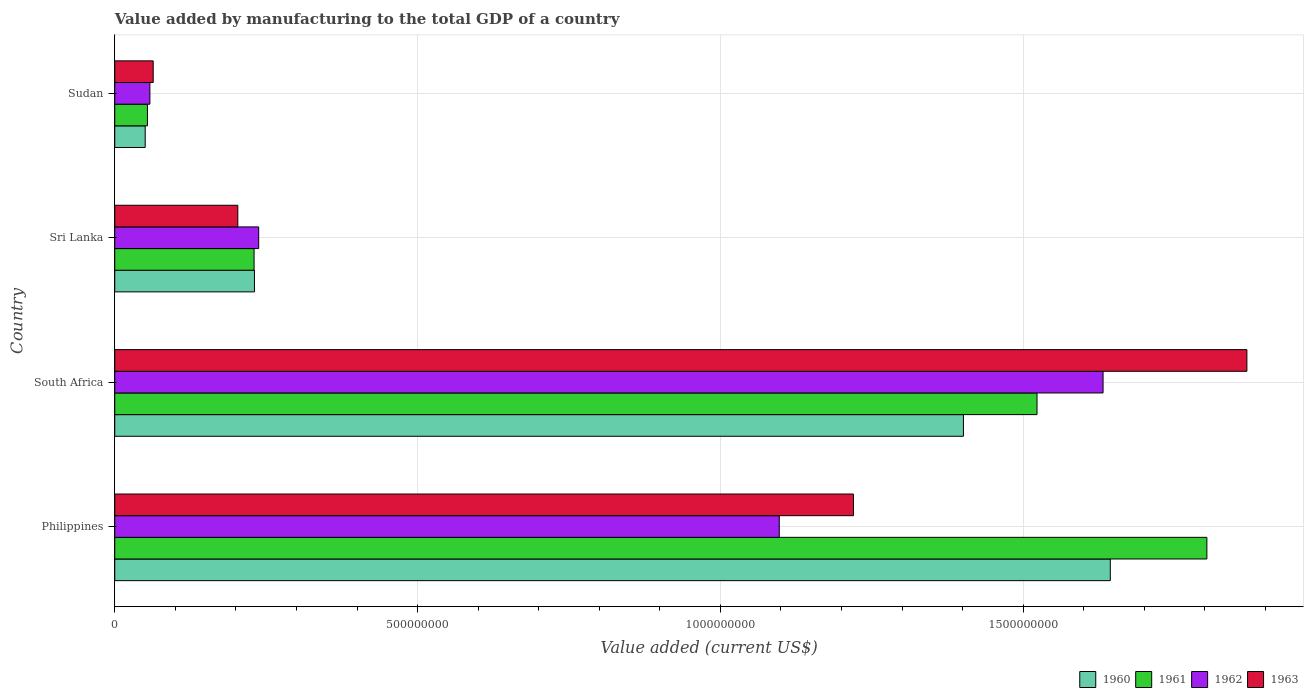Are the number of bars per tick equal to the number of legend labels?
Offer a terse response. Yes. How many bars are there on the 3rd tick from the bottom?
Give a very brief answer. 4. What is the value added by manufacturing to the total GDP in 1963 in Sudan?
Ensure brevity in your answer.  6.35e+07. Across all countries, what is the maximum value added by manufacturing to the total GDP in 1960?
Provide a short and direct response. 1.64e+09. Across all countries, what is the minimum value added by manufacturing to the total GDP in 1962?
Your response must be concise. 5.80e+07. In which country was the value added by manufacturing to the total GDP in 1963 maximum?
Offer a terse response. South Africa. In which country was the value added by manufacturing to the total GDP in 1961 minimum?
Your answer should be very brief. Sudan. What is the total value added by manufacturing to the total GDP in 1960 in the graph?
Offer a terse response. 3.33e+09. What is the difference between the value added by manufacturing to the total GDP in 1961 in Philippines and that in Sudan?
Your response must be concise. 1.75e+09. What is the difference between the value added by manufacturing to the total GDP in 1960 in Sudan and the value added by manufacturing to the total GDP in 1962 in Philippines?
Your response must be concise. -1.05e+09. What is the average value added by manufacturing to the total GDP in 1963 per country?
Your response must be concise. 8.39e+08. What is the difference between the value added by manufacturing to the total GDP in 1963 and value added by manufacturing to the total GDP in 1962 in Sudan?
Your answer should be compact. 5.46e+06. What is the ratio of the value added by manufacturing to the total GDP in 1962 in South Africa to that in Sudan?
Give a very brief answer. 28.13. Is the difference between the value added by manufacturing to the total GDP in 1963 in South Africa and Sri Lanka greater than the difference between the value added by manufacturing to the total GDP in 1962 in South Africa and Sri Lanka?
Provide a succinct answer. Yes. What is the difference between the highest and the second highest value added by manufacturing to the total GDP in 1961?
Your answer should be very brief. 2.80e+08. What is the difference between the highest and the lowest value added by manufacturing to the total GDP in 1961?
Your answer should be very brief. 1.75e+09. In how many countries, is the value added by manufacturing to the total GDP in 1961 greater than the average value added by manufacturing to the total GDP in 1961 taken over all countries?
Provide a short and direct response. 2. Is the sum of the value added by manufacturing to the total GDP in 1960 in South Africa and Sudan greater than the maximum value added by manufacturing to the total GDP in 1961 across all countries?
Your answer should be compact. No. What does the 1st bar from the bottom in Sri Lanka represents?
Give a very brief answer. 1960. How many bars are there?
Your answer should be compact. 16. How many countries are there in the graph?
Offer a very short reply. 4. Does the graph contain any zero values?
Your response must be concise. No. Does the graph contain grids?
Offer a very short reply. Yes. How many legend labels are there?
Offer a terse response. 4. How are the legend labels stacked?
Offer a very short reply. Horizontal. What is the title of the graph?
Your answer should be compact. Value added by manufacturing to the total GDP of a country. Does "1988" appear as one of the legend labels in the graph?
Offer a very short reply. No. What is the label or title of the X-axis?
Keep it short and to the point. Value added (current US$). What is the label or title of the Y-axis?
Keep it short and to the point. Country. What is the Value added (current US$) of 1960 in Philippines?
Your response must be concise. 1.64e+09. What is the Value added (current US$) of 1961 in Philippines?
Your response must be concise. 1.80e+09. What is the Value added (current US$) in 1962 in Philippines?
Your answer should be very brief. 1.10e+09. What is the Value added (current US$) in 1963 in Philippines?
Your response must be concise. 1.22e+09. What is the Value added (current US$) in 1960 in South Africa?
Your answer should be compact. 1.40e+09. What is the Value added (current US$) of 1961 in South Africa?
Provide a short and direct response. 1.52e+09. What is the Value added (current US$) in 1962 in South Africa?
Your answer should be very brief. 1.63e+09. What is the Value added (current US$) in 1963 in South Africa?
Make the answer very short. 1.87e+09. What is the Value added (current US$) of 1960 in Sri Lanka?
Make the answer very short. 2.31e+08. What is the Value added (current US$) of 1961 in Sri Lanka?
Provide a short and direct response. 2.30e+08. What is the Value added (current US$) of 1962 in Sri Lanka?
Your response must be concise. 2.38e+08. What is the Value added (current US$) of 1963 in Sri Lanka?
Offer a very short reply. 2.03e+08. What is the Value added (current US$) in 1960 in Sudan?
Provide a short and direct response. 5.03e+07. What is the Value added (current US$) of 1961 in Sudan?
Your answer should be compact. 5.40e+07. What is the Value added (current US$) in 1962 in Sudan?
Provide a succinct answer. 5.80e+07. What is the Value added (current US$) of 1963 in Sudan?
Offer a terse response. 6.35e+07. Across all countries, what is the maximum Value added (current US$) in 1960?
Give a very brief answer. 1.64e+09. Across all countries, what is the maximum Value added (current US$) in 1961?
Give a very brief answer. 1.80e+09. Across all countries, what is the maximum Value added (current US$) in 1962?
Provide a short and direct response. 1.63e+09. Across all countries, what is the maximum Value added (current US$) of 1963?
Your response must be concise. 1.87e+09. Across all countries, what is the minimum Value added (current US$) of 1960?
Ensure brevity in your answer.  5.03e+07. Across all countries, what is the minimum Value added (current US$) in 1961?
Your answer should be very brief. 5.40e+07. Across all countries, what is the minimum Value added (current US$) of 1962?
Offer a terse response. 5.80e+07. Across all countries, what is the minimum Value added (current US$) in 1963?
Ensure brevity in your answer.  6.35e+07. What is the total Value added (current US$) of 1960 in the graph?
Provide a succinct answer. 3.33e+09. What is the total Value added (current US$) of 1961 in the graph?
Provide a short and direct response. 3.61e+09. What is the total Value added (current US$) in 1962 in the graph?
Offer a terse response. 3.02e+09. What is the total Value added (current US$) of 1963 in the graph?
Your answer should be very brief. 3.36e+09. What is the difference between the Value added (current US$) of 1960 in Philippines and that in South Africa?
Give a very brief answer. 2.43e+08. What is the difference between the Value added (current US$) of 1961 in Philippines and that in South Africa?
Offer a very short reply. 2.80e+08. What is the difference between the Value added (current US$) of 1962 in Philippines and that in South Africa?
Offer a very short reply. -5.35e+08. What is the difference between the Value added (current US$) in 1963 in Philippines and that in South Africa?
Ensure brevity in your answer.  -6.50e+08. What is the difference between the Value added (current US$) of 1960 in Philippines and that in Sri Lanka?
Ensure brevity in your answer.  1.41e+09. What is the difference between the Value added (current US$) in 1961 in Philippines and that in Sri Lanka?
Your response must be concise. 1.57e+09. What is the difference between the Value added (current US$) in 1962 in Philippines and that in Sri Lanka?
Keep it short and to the point. 8.60e+08. What is the difference between the Value added (current US$) of 1963 in Philippines and that in Sri Lanka?
Give a very brief answer. 1.02e+09. What is the difference between the Value added (current US$) in 1960 in Philippines and that in Sudan?
Your answer should be compact. 1.59e+09. What is the difference between the Value added (current US$) in 1961 in Philippines and that in Sudan?
Make the answer very short. 1.75e+09. What is the difference between the Value added (current US$) of 1962 in Philippines and that in Sudan?
Offer a very short reply. 1.04e+09. What is the difference between the Value added (current US$) of 1963 in Philippines and that in Sudan?
Offer a very short reply. 1.16e+09. What is the difference between the Value added (current US$) in 1960 in South Africa and that in Sri Lanka?
Your response must be concise. 1.17e+09. What is the difference between the Value added (current US$) in 1961 in South Africa and that in Sri Lanka?
Make the answer very short. 1.29e+09. What is the difference between the Value added (current US$) of 1962 in South Africa and that in Sri Lanka?
Provide a short and direct response. 1.39e+09. What is the difference between the Value added (current US$) in 1963 in South Africa and that in Sri Lanka?
Your answer should be very brief. 1.67e+09. What is the difference between the Value added (current US$) of 1960 in South Africa and that in Sudan?
Offer a terse response. 1.35e+09. What is the difference between the Value added (current US$) in 1961 in South Africa and that in Sudan?
Provide a succinct answer. 1.47e+09. What is the difference between the Value added (current US$) of 1962 in South Africa and that in Sudan?
Offer a very short reply. 1.57e+09. What is the difference between the Value added (current US$) in 1963 in South Africa and that in Sudan?
Your answer should be very brief. 1.81e+09. What is the difference between the Value added (current US$) in 1960 in Sri Lanka and that in Sudan?
Give a very brief answer. 1.80e+08. What is the difference between the Value added (current US$) in 1961 in Sri Lanka and that in Sudan?
Your answer should be compact. 1.76e+08. What is the difference between the Value added (current US$) in 1962 in Sri Lanka and that in Sudan?
Offer a very short reply. 1.80e+08. What is the difference between the Value added (current US$) in 1963 in Sri Lanka and that in Sudan?
Provide a short and direct response. 1.40e+08. What is the difference between the Value added (current US$) of 1960 in Philippines and the Value added (current US$) of 1961 in South Africa?
Offer a terse response. 1.21e+08. What is the difference between the Value added (current US$) in 1960 in Philippines and the Value added (current US$) in 1962 in South Africa?
Give a very brief answer. 1.19e+07. What is the difference between the Value added (current US$) of 1960 in Philippines and the Value added (current US$) of 1963 in South Africa?
Keep it short and to the point. -2.26e+08. What is the difference between the Value added (current US$) in 1961 in Philippines and the Value added (current US$) in 1962 in South Africa?
Your answer should be compact. 1.71e+08. What is the difference between the Value added (current US$) of 1961 in Philippines and the Value added (current US$) of 1963 in South Africa?
Your answer should be very brief. -6.61e+07. What is the difference between the Value added (current US$) in 1962 in Philippines and the Value added (current US$) in 1963 in South Africa?
Provide a succinct answer. -7.72e+08. What is the difference between the Value added (current US$) of 1960 in Philippines and the Value added (current US$) of 1961 in Sri Lanka?
Your answer should be very brief. 1.41e+09. What is the difference between the Value added (current US$) in 1960 in Philippines and the Value added (current US$) in 1962 in Sri Lanka?
Make the answer very short. 1.41e+09. What is the difference between the Value added (current US$) in 1960 in Philippines and the Value added (current US$) in 1963 in Sri Lanka?
Offer a terse response. 1.44e+09. What is the difference between the Value added (current US$) in 1961 in Philippines and the Value added (current US$) in 1962 in Sri Lanka?
Give a very brief answer. 1.57e+09. What is the difference between the Value added (current US$) in 1961 in Philippines and the Value added (current US$) in 1963 in Sri Lanka?
Ensure brevity in your answer.  1.60e+09. What is the difference between the Value added (current US$) in 1962 in Philippines and the Value added (current US$) in 1963 in Sri Lanka?
Your answer should be compact. 8.94e+08. What is the difference between the Value added (current US$) of 1960 in Philippines and the Value added (current US$) of 1961 in Sudan?
Your answer should be very brief. 1.59e+09. What is the difference between the Value added (current US$) of 1960 in Philippines and the Value added (current US$) of 1962 in Sudan?
Offer a terse response. 1.59e+09. What is the difference between the Value added (current US$) in 1960 in Philippines and the Value added (current US$) in 1963 in Sudan?
Provide a short and direct response. 1.58e+09. What is the difference between the Value added (current US$) of 1961 in Philippines and the Value added (current US$) of 1962 in Sudan?
Offer a very short reply. 1.75e+09. What is the difference between the Value added (current US$) of 1961 in Philippines and the Value added (current US$) of 1963 in Sudan?
Provide a succinct answer. 1.74e+09. What is the difference between the Value added (current US$) of 1962 in Philippines and the Value added (current US$) of 1963 in Sudan?
Your answer should be compact. 1.03e+09. What is the difference between the Value added (current US$) of 1960 in South Africa and the Value added (current US$) of 1961 in Sri Lanka?
Your answer should be very brief. 1.17e+09. What is the difference between the Value added (current US$) of 1960 in South Africa and the Value added (current US$) of 1962 in Sri Lanka?
Provide a short and direct response. 1.16e+09. What is the difference between the Value added (current US$) in 1960 in South Africa and the Value added (current US$) in 1963 in Sri Lanka?
Ensure brevity in your answer.  1.20e+09. What is the difference between the Value added (current US$) of 1961 in South Africa and the Value added (current US$) of 1962 in Sri Lanka?
Offer a very short reply. 1.29e+09. What is the difference between the Value added (current US$) of 1961 in South Africa and the Value added (current US$) of 1963 in Sri Lanka?
Ensure brevity in your answer.  1.32e+09. What is the difference between the Value added (current US$) of 1962 in South Africa and the Value added (current US$) of 1963 in Sri Lanka?
Keep it short and to the point. 1.43e+09. What is the difference between the Value added (current US$) of 1960 in South Africa and the Value added (current US$) of 1961 in Sudan?
Keep it short and to the point. 1.35e+09. What is the difference between the Value added (current US$) in 1960 in South Africa and the Value added (current US$) in 1962 in Sudan?
Make the answer very short. 1.34e+09. What is the difference between the Value added (current US$) of 1960 in South Africa and the Value added (current US$) of 1963 in Sudan?
Your response must be concise. 1.34e+09. What is the difference between the Value added (current US$) of 1961 in South Africa and the Value added (current US$) of 1962 in Sudan?
Offer a very short reply. 1.46e+09. What is the difference between the Value added (current US$) in 1961 in South Africa and the Value added (current US$) in 1963 in Sudan?
Your answer should be very brief. 1.46e+09. What is the difference between the Value added (current US$) in 1962 in South Africa and the Value added (current US$) in 1963 in Sudan?
Provide a succinct answer. 1.57e+09. What is the difference between the Value added (current US$) of 1960 in Sri Lanka and the Value added (current US$) of 1961 in Sudan?
Make the answer very short. 1.77e+08. What is the difference between the Value added (current US$) of 1960 in Sri Lanka and the Value added (current US$) of 1962 in Sudan?
Ensure brevity in your answer.  1.73e+08. What is the difference between the Value added (current US$) of 1960 in Sri Lanka and the Value added (current US$) of 1963 in Sudan?
Ensure brevity in your answer.  1.67e+08. What is the difference between the Value added (current US$) in 1961 in Sri Lanka and the Value added (current US$) in 1962 in Sudan?
Your answer should be compact. 1.72e+08. What is the difference between the Value added (current US$) of 1961 in Sri Lanka and the Value added (current US$) of 1963 in Sudan?
Ensure brevity in your answer.  1.67e+08. What is the difference between the Value added (current US$) in 1962 in Sri Lanka and the Value added (current US$) in 1963 in Sudan?
Offer a terse response. 1.74e+08. What is the average Value added (current US$) in 1960 per country?
Provide a succinct answer. 8.32e+08. What is the average Value added (current US$) in 1961 per country?
Offer a very short reply. 9.03e+08. What is the average Value added (current US$) in 1962 per country?
Your response must be concise. 7.56e+08. What is the average Value added (current US$) in 1963 per country?
Your response must be concise. 8.39e+08. What is the difference between the Value added (current US$) in 1960 and Value added (current US$) in 1961 in Philippines?
Offer a terse response. -1.59e+08. What is the difference between the Value added (current US$) in 1960 and Value added (current US$) in 1962 in Philippines?
Provide a short and direct response. 5.47e+08. What is the difference between the Value added (current US$) in 1960 and Value added (current US$) in 1963 in Philippines?
Provide a short and direct response. 4.24e+08. What is the difference between the Value added (current US$) of 1961 and Value added (current US$) of 1962 in Philippines?
Keep it short and to the point. 7.06e+08. What is the difference between the Value added (current US$) of 1961 and Value added (current US$) of 1963 in Philippines?
Ensure brevity in your answer.  5.84e+08. What is the difference between the Value added (current US$) of 1962 and Value added (current US$) of 1963 in Philippines?
Give a very brief answer. -1.22e+08. What is the difference between the Value added (current US$) of 1960 and Value added (current US$) of 1961 in South Africa?
Provide a short and direct response. -1.21e+08. What is the difference between the Value added (current US$) in 1960 and Value added (current US$) in 1962 in South Africa?
Provide a succinct answer. -2.31e+08. What is the difference between the Value added (current US$) in 1960 and Value added (current US$) in 1963 in South Africa?
Provide a succinct answer. -4.68e+08. What is the difference between the Value added (current US$) of 1961 and Value added (current US$) of 1962 in South Africa?
Provide a short and direct response. -1.09e+08. What is the difference between the Value added (current US$) of 1961 and Value added (current US$) of 1963 in South Africa?
Offer a very short reply. -3.47e+08. What is the difference between the Value added (current US$) in 1962 and Value added (current US$) in 1963 in South Africa?
Keep it short and to the point. -2.37e+08. What is the difference between the Value added (current US$) in 1960 and Value added (current US$) in 1961 in Sri Lanka?
Your answer should be compact. 6.30e+05. What is the difference between the Value added (current US$) in 1960 and Value added (current US$) in 1962 in Sri Lanka?
Offer a terse response. -6.98e+06. What is the difference between the Value added (current US$) in 1960 and Value added (current US$) in 1963 in Sri Lanka?
Make the answer very short. 2.75e+07. What is the difference between the Value added (current US$) of 1961 and Value added (current US$) of 1962 in Sri Lanka?
Make the answer very short. -7.61e+06. What is the difference between the Value added (current US$) of 1961 and Value added (current US$) of 1963 in Sri Lanka?
Offer a very short reply. 2.68e+07. What is the difference between the Value added (current US$) of 1962 and Value added (current US$) of 1963 in Sri Lanka?
Ensure brevity in your answer.  3.45e+07. What is the difference between the Value added (current US$) of 1960 and Value added (current US$) of 1961 in Sudan?
Offer a terse response. -3.73e+06. What is the difference between the Value added (current US$) in 1960 and Value added (current US$) in 1962 in Sudan?
Offer a terse response. -7.75e+06. What is the difference between the Value added (current US$) of 1960 and Value added (current US$) of 1963 in Sudan?
Keep it short and to the point. -1.32e+07. What is the difference between the Value added (current US$) in 1961 and Value added (current US$) in 1962 in Sudan?
Provide a short and direct response. -4.02e+06. What is the difference between the Value added (current US$) in 1961 and Value added (current US$) in 1963 in Sudan?
Provide a succinct answer. -9.48e+06. What is the difference between the Value added (current US$) in 1962 and Value added (current US$) in 1963 in Sudan?
Offer a very short reply. -5.46e+06. What is the ratio of the Value added (current US$) of 1960 in Philippines to that in South Africa?
Offer a terse response. 1.17. What is the ratio of the Value added (current US$) in 1961 in Philippines to that in South Africa?
Your answer should be compact. 1.18. What is the ratio of the Value added (current US$) of 1962 in Philippines to that in South Africa?
Offer a terse response. 0.67. What is the ratio of the Value added (current US$) of 1963 in Philippines to that in South Africa?
Ensure brevity in your answer.  0.65. What is the ratio of the Value added (current US$) of 1960 in Philippines to that in Sri Lanka?
Your answer should be very brief. 7.13. What is the ratio of the Value added (current US$) of 1961 in Philippines to that in Sri Lanka?
Your answer should be very brief. 7.84. What is the ratio of the Value added (current US$) of 1962 in Philippines to that in Sri Lanka?
Your response must be concise. 4.62. What is the ratio of the Value added (current US$) in 1963 in Philippines to that in Sri Lanka?
Provide a succinct answer. 6. What is the ratio of the Value added (current US$) of 1960 in Philippines to that in Sudan?
Your answer should be compact. 32.71. What is the ratio of the Value added (current US$) in 1961 in Philippines to that in Sudan?
Give a very brief answer. 33.4. What is the ratio of the Value added (current US$) in 1962 in Philippines to that in Sudan?
Provide a succinct answer. 18.91. What is the ratio of the Value added (current US$) of 1963 in Philippines to that in Sudan?
Give a very brief answer. 19.22. What is the ratio of the Value added (current US$) of 1960 in South Africa to that in Sri Lanka?
Give a very brief answer. 6.08. What is the ratio of the Value added (current US$) in 1961 in South Africa to that in Sri Lanka?
Your response must be concise. 6.62. What is the ratio of the Value added (current US$) in 1962 in South Africa to that in Sri Lanka?
Offer a terse response. 6.87. What is the ratio of the Value added (current US$) in 1963 in South Africa to that in Sri Lanka?
Keep it short and to the point. 9.2. What is the ratio of the Value added (current US$) of 1960 in South Africa to that in Sudan?
Offer a terse response. 27.88. What is the ratio of the Value added (current US$) in 1961 in South Africa to that in Sudan?
Your answer should be very brief. 28.21. What is the ratio of the Value added (current US$) in 1962 in South Africa to that in Sudan?
Give a very brief answer. 28.13. What is the ratio of the Value added (current US$) in 1963 in South Africa to that in Sudan?
Offer a terse response. 29.45. What is the ratio of the Value added (current US$) of 1960 in Sri Lanka to that in Sudan?
Offer a very short reply. 4.59. What is the ratio of the Value added (current US$) of 1961 in Sri Lanka to that in Sudan?
Keep it short and to the point. 4.26. What is the ratio of the Value added (current US$) of 1962 in Sri Lanka to that in Sudan?
Offer a very short reply. 4.1. What is the ratio of the Value added (current US$) in 1963 in Sri Lanka to that in Sudan?
Your answer should be compact. 3.2. What is the difference between the highest and the second highest Value added (current US$) of 1960?
Offer a very short reply. 2.43e+08. What is the difference between the highest and the second highest Value added (current US$) in 1961?
Ensure brevity in your answer.  2.80e+08. What is the difference between the highest and the second highest Value added (current US$) in 1962?
Your answer should be very brief. 5.35e+08. What is the difference between the highest and the second highest Value added (current US$) of 1963?
Ensure brevity in your answer.  6.50e+08. What is the difference between the highest and the lowest Value added (current US$) of 1960?
Ensure brevity in your answer.  1.59e+09. What is the difference between the highest and the lowest Value added (current US$) in 1961?
Provide a succinct answer. 1.75e+09. What is the difference between the highest and the lowest Value added (current US$) in 1962?
Give a very brief answer. 1.57e+09. What is the difference between the highest and the lowest Value added (current US$) of 1963?
Give a very brief answer. 1.81e+09. 